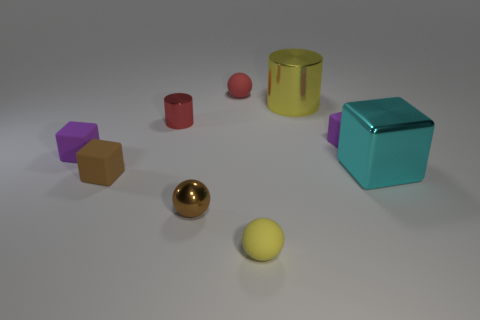Is the color of the large cube the same as the big metallic cylinder?
Your answer should be compact. No. There is a object that is on the right side of the yellow cylinder and behind the large block; what is its shape?
Keep it short and to the point. Cube. How many other objects are the same color as the small cylinder?
Keep it short and to the point. 1. There is a yellow rubber thing; what shape is it?
Your answer should be very brief. Sphere. There is a cylinder on the right side of the rubber thing in front of the small brown shiny sphere; what is its color?
Give a very brief answer. Yellow. Do the tiny metallic sphere and the tiny rubber sphere that is in front of the small brown rubber block have the same color?
Your answer should be very brief. No. There is a tiny sphere that is in front of the cyan thing and on the left side of the tiny yellow thing; what is its material?
Offer a very short reply. Metal. Is there another ball that has the same size as the yellow ball?
Ensure brevity in your answer.  Yes. There is a cube that is the same size as the yellow metallic object; what is it made of?
Your answer should be compact. Metal. What number of tiny red shiny objects are on the right side of the cyan object?
Your response must be concise. 0. 